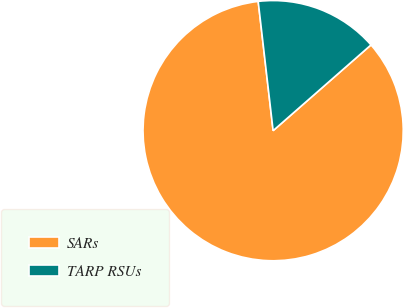Convert chart. <chart><loc_0><loc_0><loc_500><loc_500><pie_chart><fcel>SARs<fcel>TARP RSUs<nl><fcel>84.62%<fcel>15.38%<nl></chart> 